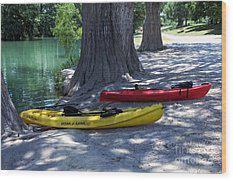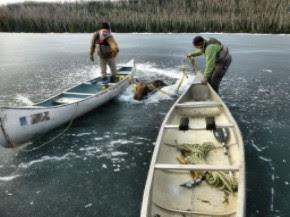The first image is the image on the left, the second image is the image on the right. For the images displayed, is the sentence "In one image, two green canoes are side by side" factually correct? Answer yes or no. No. The first image is the image on the left, the second image is the image on the right. Evaluate the accuracy of this statement regarding the images: "In one picture the canoes are in the water and in the other picture the canoes are not in the water.". Is it true? Answer yes or no. Yes. The first image is the image on the left, the second image is the image on the right. Examine the images to the left and right. Is the description "There is at least one human standing inside a boat while the boat is in the water." accurate? Answer yes or no. Yes. The first image is the image on the left, the second image is the image on the right. Given the left and right images, does the statement "There is three humans in the right image." hold true? Answer yes or no. No. 